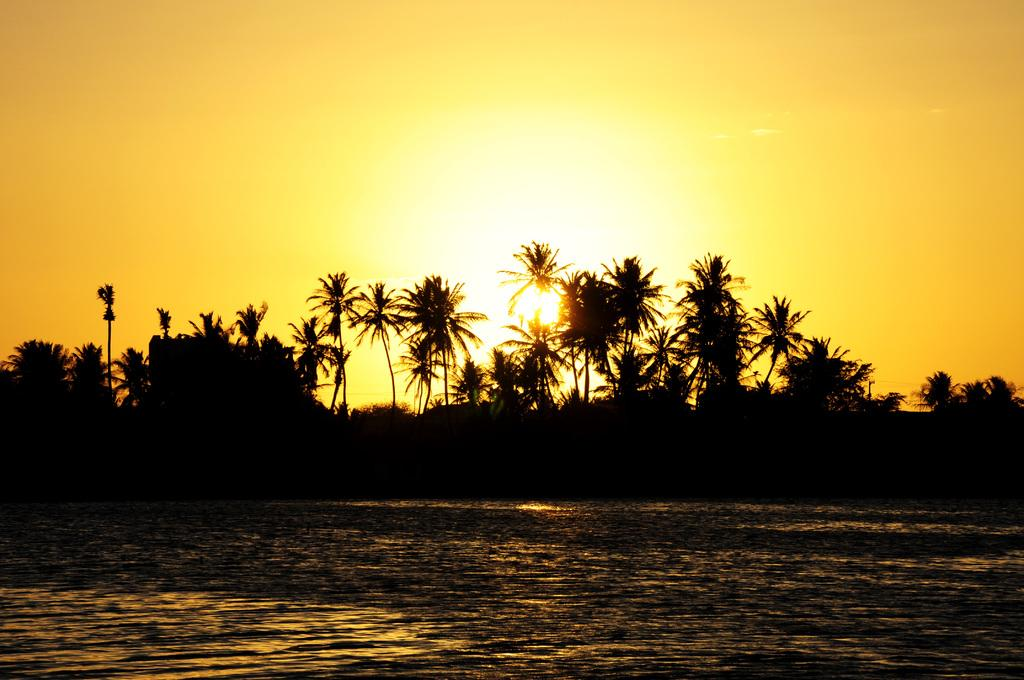What type of vegetation can be seen in the image? There are trees in the image. What is visible at the top of the image? The sky is visible at the top of the image. Can you describe the celestial body in the sky? The sun is present in the sky. What can be seen at the bottom of the image? There is water visible at the bottom of the image. Where is the faucet located in the image? There is no faucet present in the image. What type of zipper can be seen on the trees in the image? There are no zippers on the trees in the image; they are natural vegetation. 